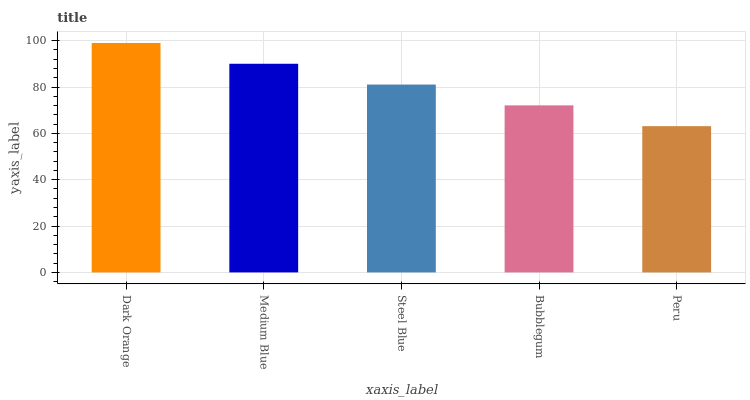Is Peru the minimum?
Answer yes or no. Yes. Is Dark Orange the maximum?
Answer yes or no. Yes. Is Medium Blue the minimum?
Answer yes or no. No. Is Medium Blue the maximum?
Answer yes or no. No. Is Dark Orange greater than Medium Blue?
Answer yes or no. Yes. Is Medium Blue less than Dark Orange?
Answer yes or no. Yes. Is Medium Blue greater than Dark Orange?
Answer yes or no. No. Is Dark Orange less than Medium Blue?
Answer yes or no. No. Is Steel Blue the high median?
Answer yes or no. Yes. Is Steel Blue the low median?
Answer yes or no. Yes. Is Peru the high median?
Answer yes or no. No. Is Bubblegum the low median?
Answer yes or no. No. 